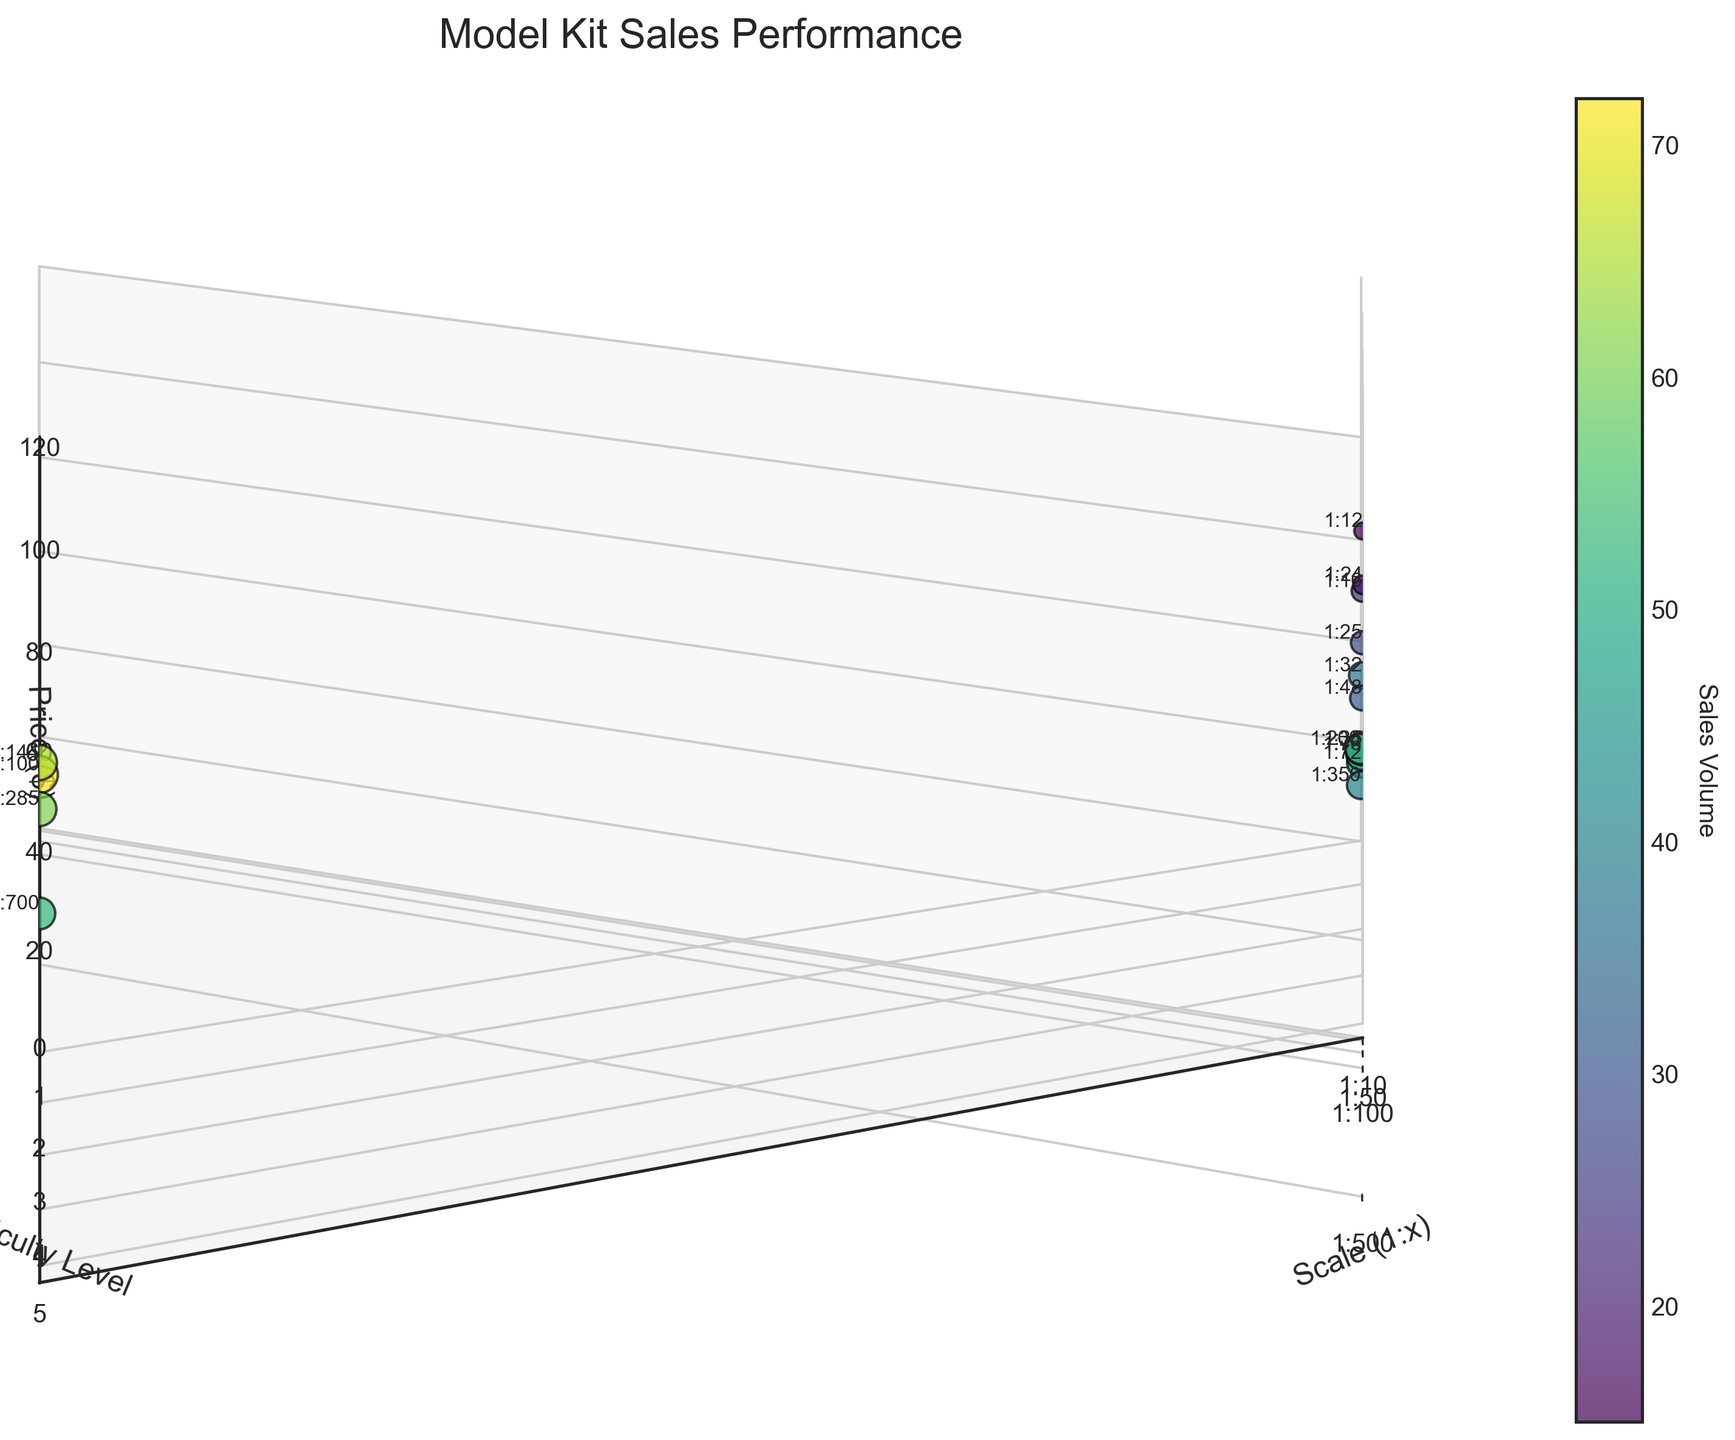How many data points are in the figure? To determine the number of data points, count the number of distinct scatter points in the plot. By examining the figure, there are 15 data points represented by dots.
Answer: 15 What is the title of the plot? The title of a plot is usually positioned at the top. In this case, it's "Model Kit Sales Performance."
Answer: Model Kit Sales Performance Which scale has the highest sales volume? The sales volume is indicated by the color and size of the scatter points. The data point with the highest sales volume is the one with the darkest color and largest size, which corresponds to the scale 1:100.
Answer: 1:100 What is the price range displayed on the z-axis? The price range can be identified by looking at the labels on the z-axis. The range goes from $0 to $120.
Answer: $0 to $120 Which data point has the highest difficulty level and what are its corresponding sales? The highest difficulty level is 5. Locate the data points at this level on the y-axis and find the corresponding sales values. The scales with difficulty level 5 are 1:24 and 1:12, with sales volumes of 18 and 15, respectively.
Answer: 1:24 and 1:12 have sales of 18 and 15 What is the relationship between price and sales volume for the scales 1:200 and 1:35? To understand the relationship, observe these two scales on the 3D scatter plot. For scale 1:200, the price is $39.99 and the sales volume is 47. For scale 1:35, the price is $39.99 and the sales volume is 58. Despite having the same price, 1:35 has a higher sales volume.
Answer: Higher sales for 1:35 Which scale with a difficulty level of 4 has the lowest price and what are its sales? Check the data points at difficulty level 4 and compare their prices. The scales at this level are 1:48, 1:16, and 1:25 with prices of $59.99, $79.99, and $69.99 respectively. Hence, 1:48 has the lowest price with sales of 32.
Answer: 1:48 with sales of 32 What is the average price of all model kits with a difficulty level of 1? Summarize the prices of the model kits with difficulty 1, which are 1:100 ($19.99), 1:144 ($24.99), and 1:285 ($22.99). The average price is: ($19.99 + $24.99 + $22.99) / 3 = $22.66.
Answer: $22.66 Which scale has the most balanced combination of price and sales volume? Observe the scatter points to identify the scale with a mid-range price and moderate sales volume. Scale 1:72, with a price of $29.99 and sales of 45, appears balanced.
Answer: 1:72 How does the sales volume trend with increasing difficulty levels for similar scales? Compare the scales with varying difficulty levels along the y-axis while keeping the scale range constant. Observation would show that, for instance, the scales with prices around $30 to $40, like 1:72 (difficulty 2, sales 45) and 1:200 (difficulty 2, sales 47), have higher sales than the higher difficulty scales like 1:48 (difficulty 4, sales 32) and 1:16 (difficulty 4, sales 25).
Answer: Higher difficulty, generally lower sales 